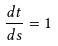<formula> <loc_0><loc_0><loc_500><loc_500>\frac { d t } { d s } = 1</formula> 